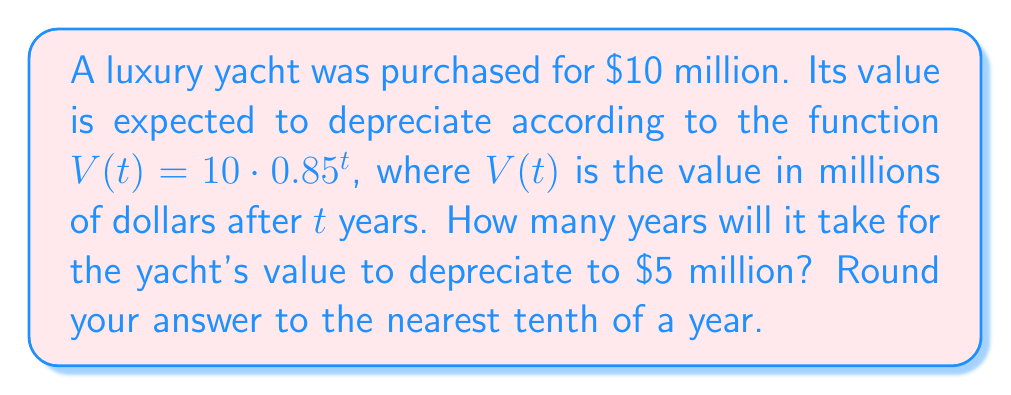Help me with this question. Let's approach this step-by-step:

1) We need to solve the equation:
   $5 = 10 \cdot 0.85^t$

2) Divide both sides by 10:
   $0.5 = 0.85^t$

3) Take the natural logarithm of both sides:
   $\ln(0.5) = \ln(0.85^t)$

4) Use the logarithm property $\ln(a^b) = b\ln(a)$:
   $\ln(0.5) = t \cdot \ln(0.85)$

5) Solve for $t$:
   $t = \frac{\ln(0.5)}{\ln(0.85)}$

6) Calculate using a calculator:
   $t \approx 4.2735$

7) Rounding to the nearest tenth:
   $t \approx 4.3$ years
Answer: 4.3 years 